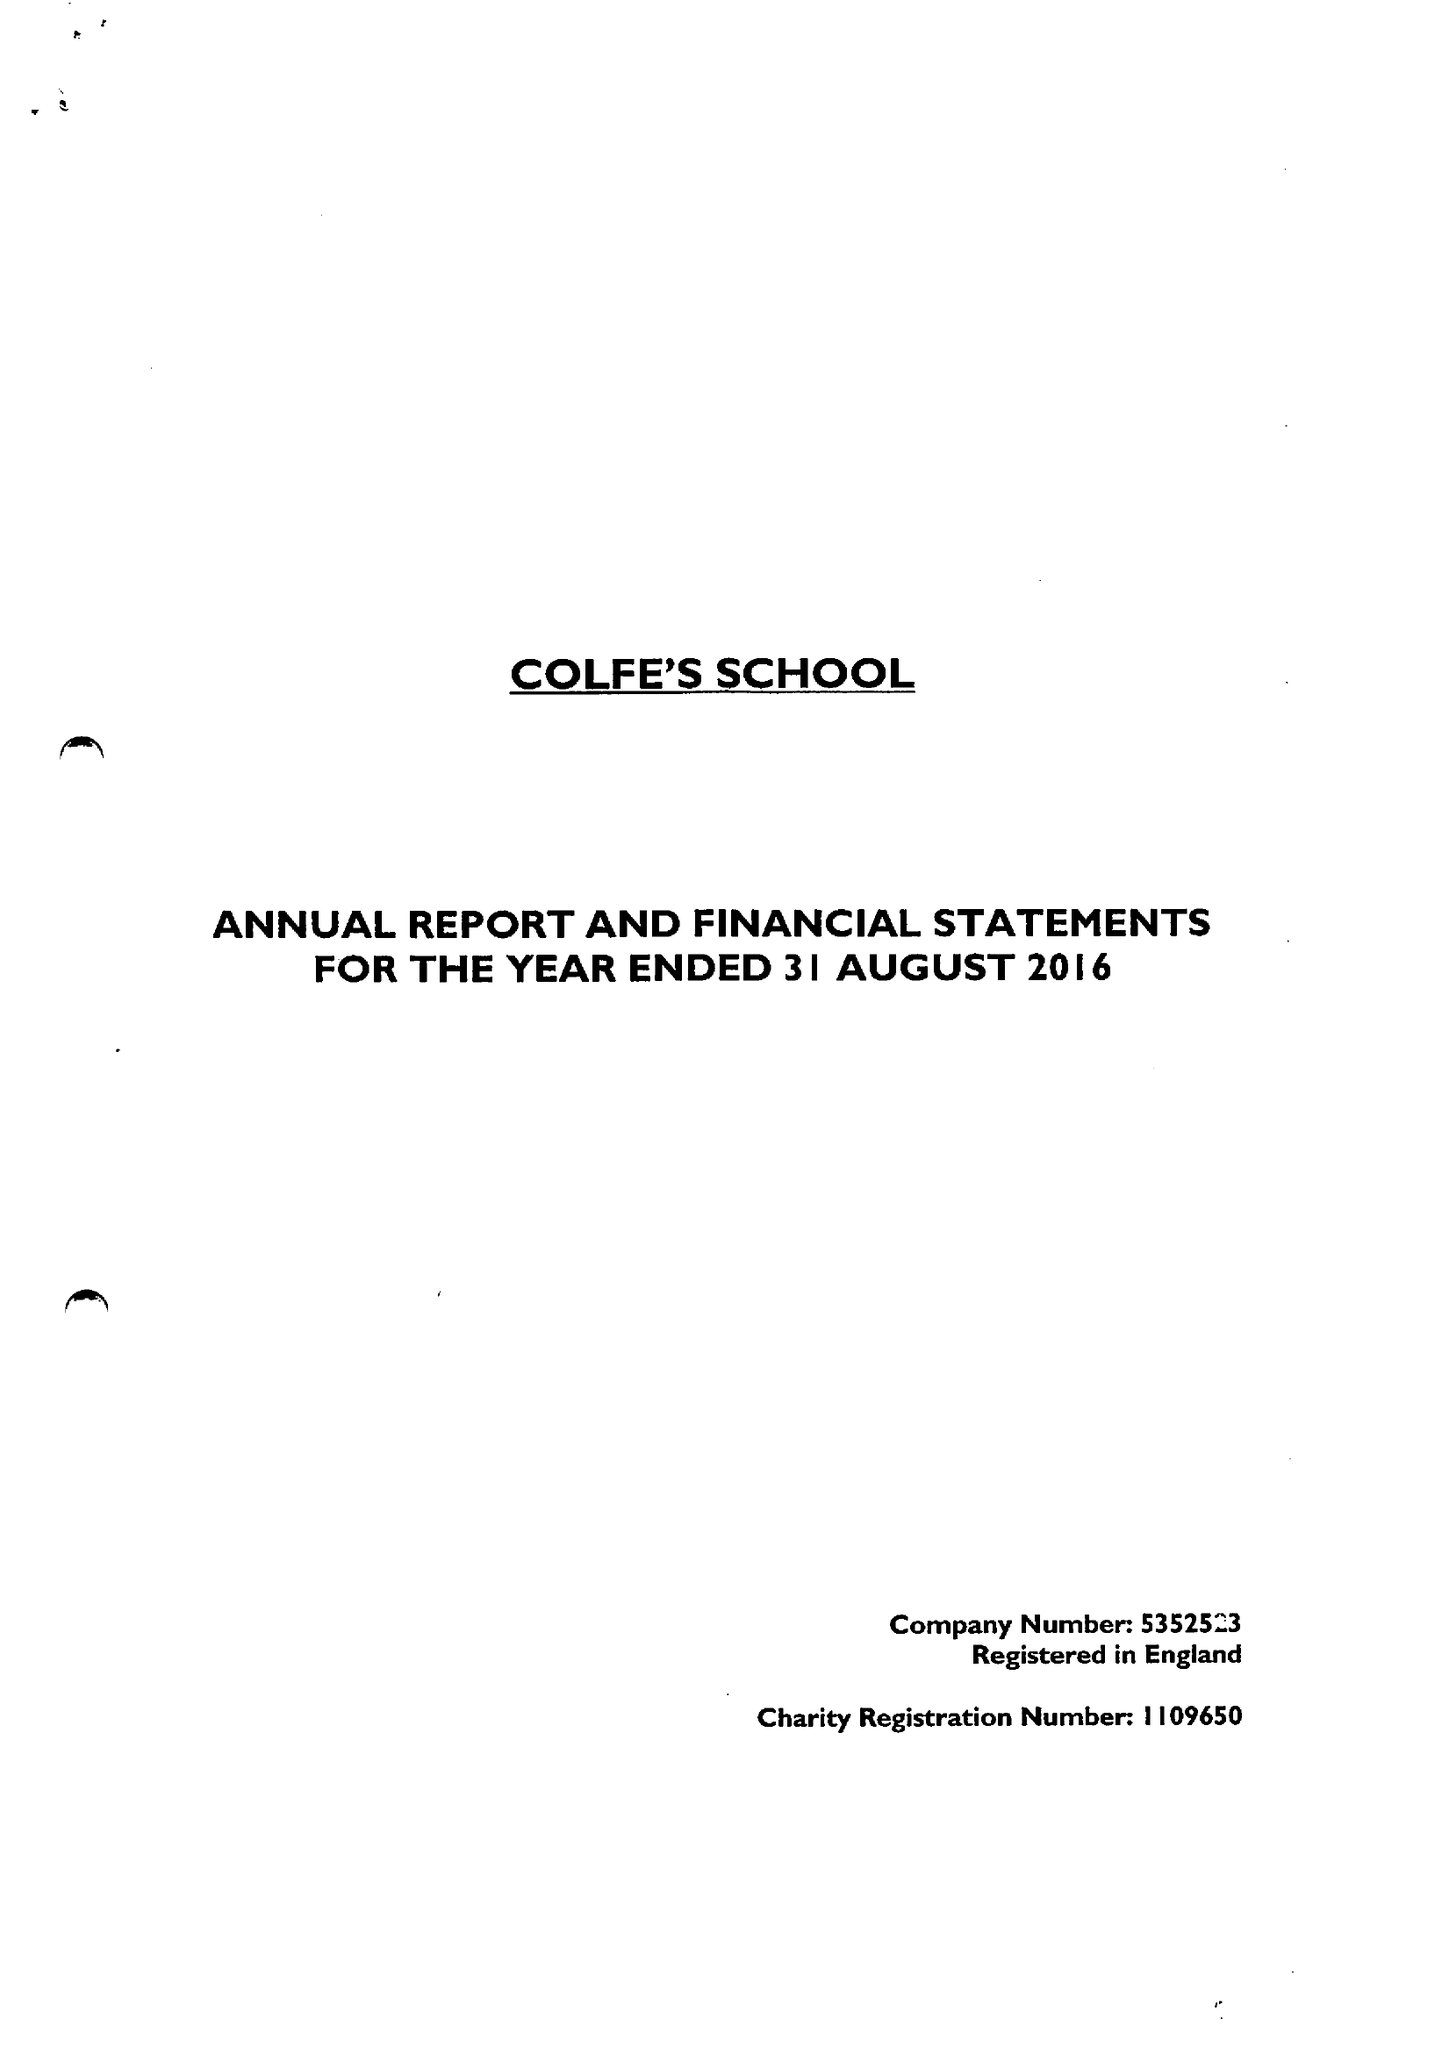What is the value for the spending_annually_in_british_pounds?
Answer the question using a single word or phrase. 15508000.00 